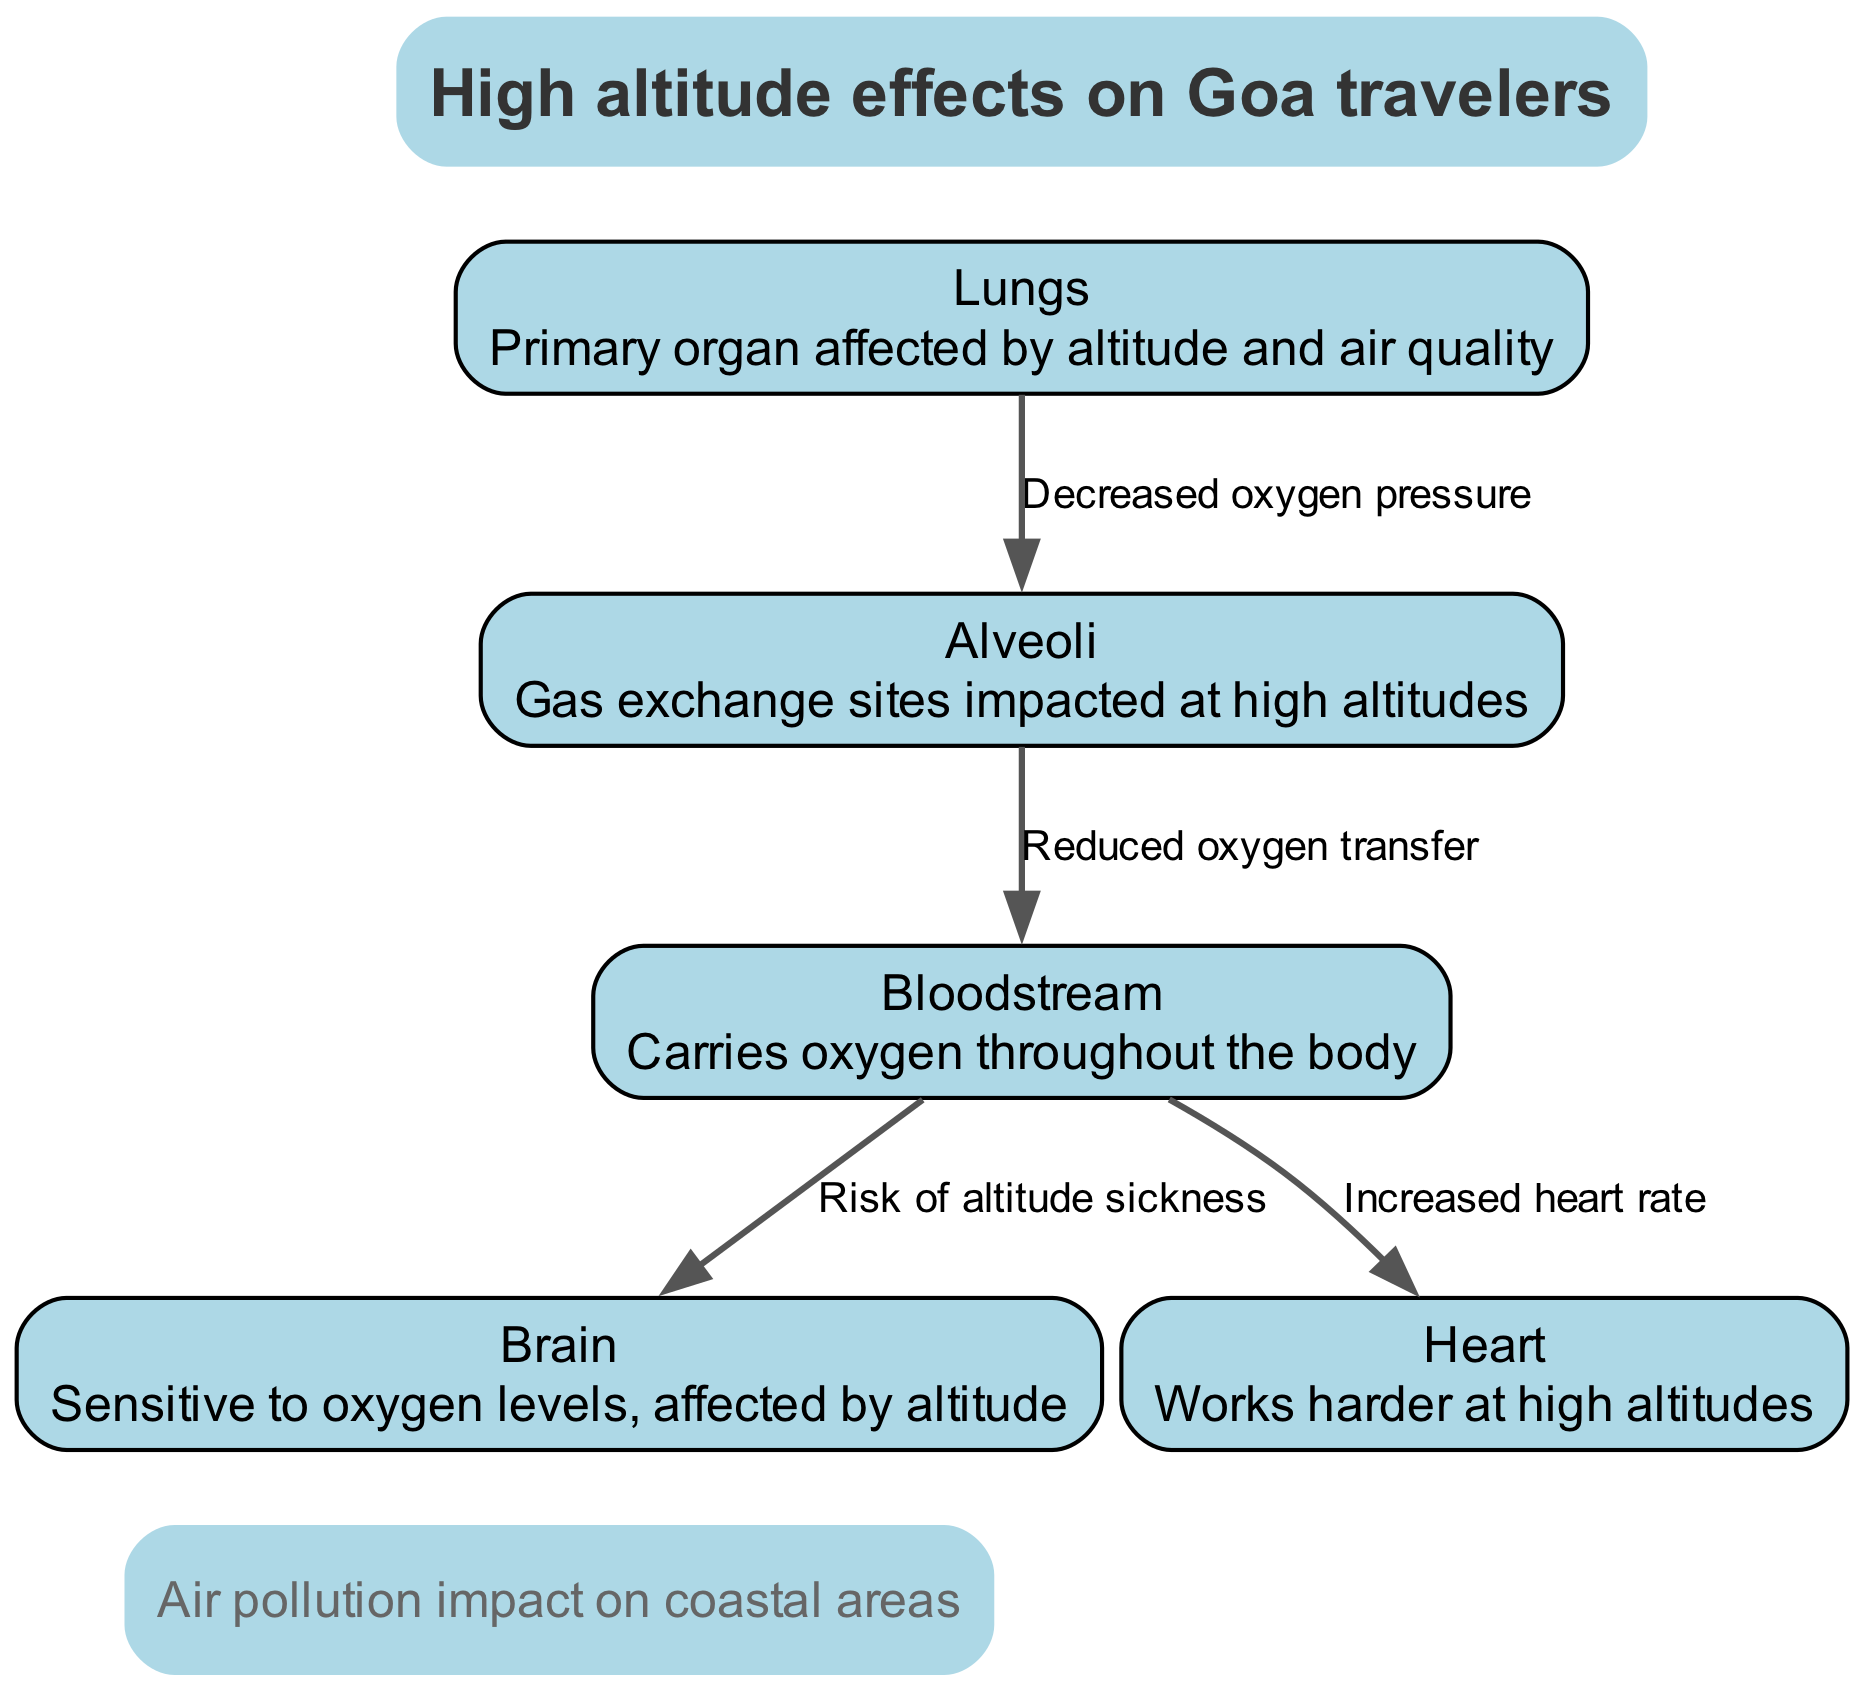What are the primary organs affected by altitude and air quality? The diagram identifies "Lungs" as the primary organ affected by altitude and air quality. This is explicitly stated in the node description for "Lungs."
Answer: Lungs What is the relationship between the alveoli and the bloodstream? The edge connecting "Alveoli" to "Bloodstream" is labeled "Reduced oxygen transfer," which indicates that the alveoli's efficiency in transferring oxygen to the bloodstream is compromised.
Answer: Reduced oxygen transfer How many nodes are shown in this diagram? The diagram includes a total of five distinct nodes: Lungs, Alveoli, Bloodstream, Brain, and Heart. By counting each one, the total is established.
Answer: 5 What impact does high altitude have on the brain as per the diagram? The diagram indicates that the "Bloodstream" risks "Altitude sickness" that affects the "Brain." This shows that low oxygen levels in the bloodstream can lead to altitude sickness, impacting brain function.
Answer: Risk of altitude sickness How does high altitude affect the heart according to the diagram? There is a direct connection from "Bloodstream" to "Heart," labeled "Increased heart rate," indicating that at high altitudes, the heart needs to work harder to pump oxygen to the body due to lower oxygen availability.
Answer: Increased heart rate What effect does air pollution have on coastal areas mentioned in the diagram? The diagram contains an annotation that states "Air pollution impact on coastal areas," suggesting that air quality is a concern for travelers to coastal regions, including Goa.
Answer: Air pollution impact on coastal areas Which node is described as sensitive to oxygen levels? The diagram specifically describes the "Brain" as sensitive to oxygen levels, noting its vulnerability, especially at high altitudes.
Answer: Brain What does decreased oxygen pressure from lungs lead to? The edge from "Lungs" to "Alveoli" is labeled "Decreased oxygen pressure," indicating that when oxygen pressure decreases in the lungs, it has a direct effect on the alveoli's gas exchange function.
Answer: Decreased oxygen pressure What are the implications of high altitude effects on Goa travelers? The annotation at the top of the diagram refers to the "High altitude effects on Goa travelers," summarizing that travelers to high altitudes may experience physiological stress due to reduced oxygen levels.
Answer: High altitude effects on Goa travelers 